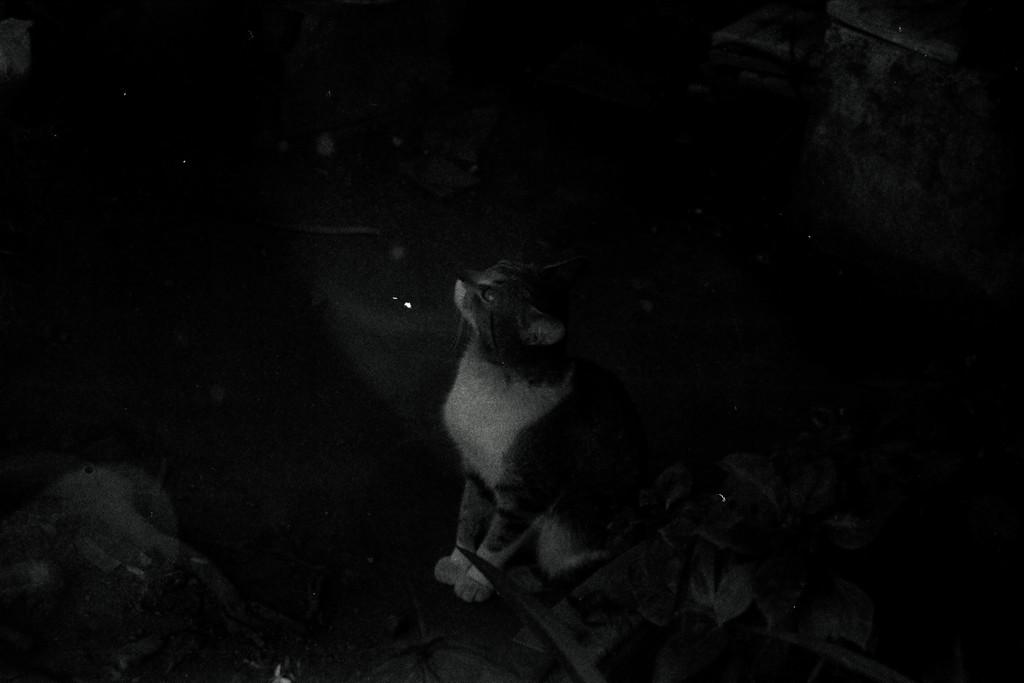What is the color scheme of the image? The image is black and white. What animal can be seen in the image? There is a cat in the image. Where is the cat located in the image? The cat is sitting on the floor. How would you describe the overall lighting or brightness of the image? The remaining parts of the image are dark. What type of lunchroom equipment can be seen in the image? There is no lunchroom equipment present in the image; it features a black and white image of a cat sitting on the floor. What type of oven is visible in the image? There is no oven present in the image; it features a black and white image of a cat sitting on the floor. 